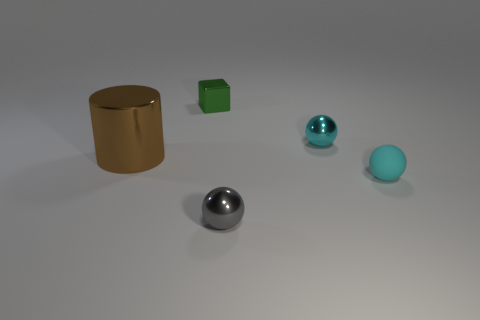Subtract all blue cylinders. Subtract all brown blocks. How many cylinders are left? 1 Add 5 big brown metal cylinders. How many objects exist? 10 Subtract all spheres. How many objects are left? 2 Add 4 blue matte objects. How many blue matte objects exist? 4 Subtract 0 cyan cubes. How many objects are left? 5 Subtract all cyan rubber cylinders. Subtract all brown shiny objects. How many objects are left? 4 Add 5 gray metal spheres. How many gray metal spheres are left? 6 